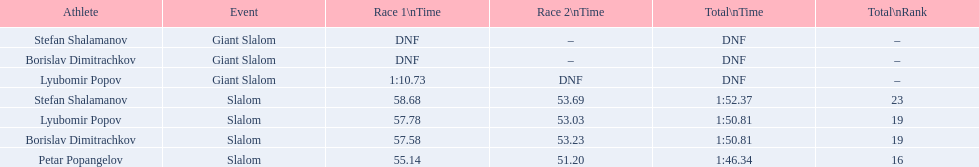How many athletes exist in total? 4. 